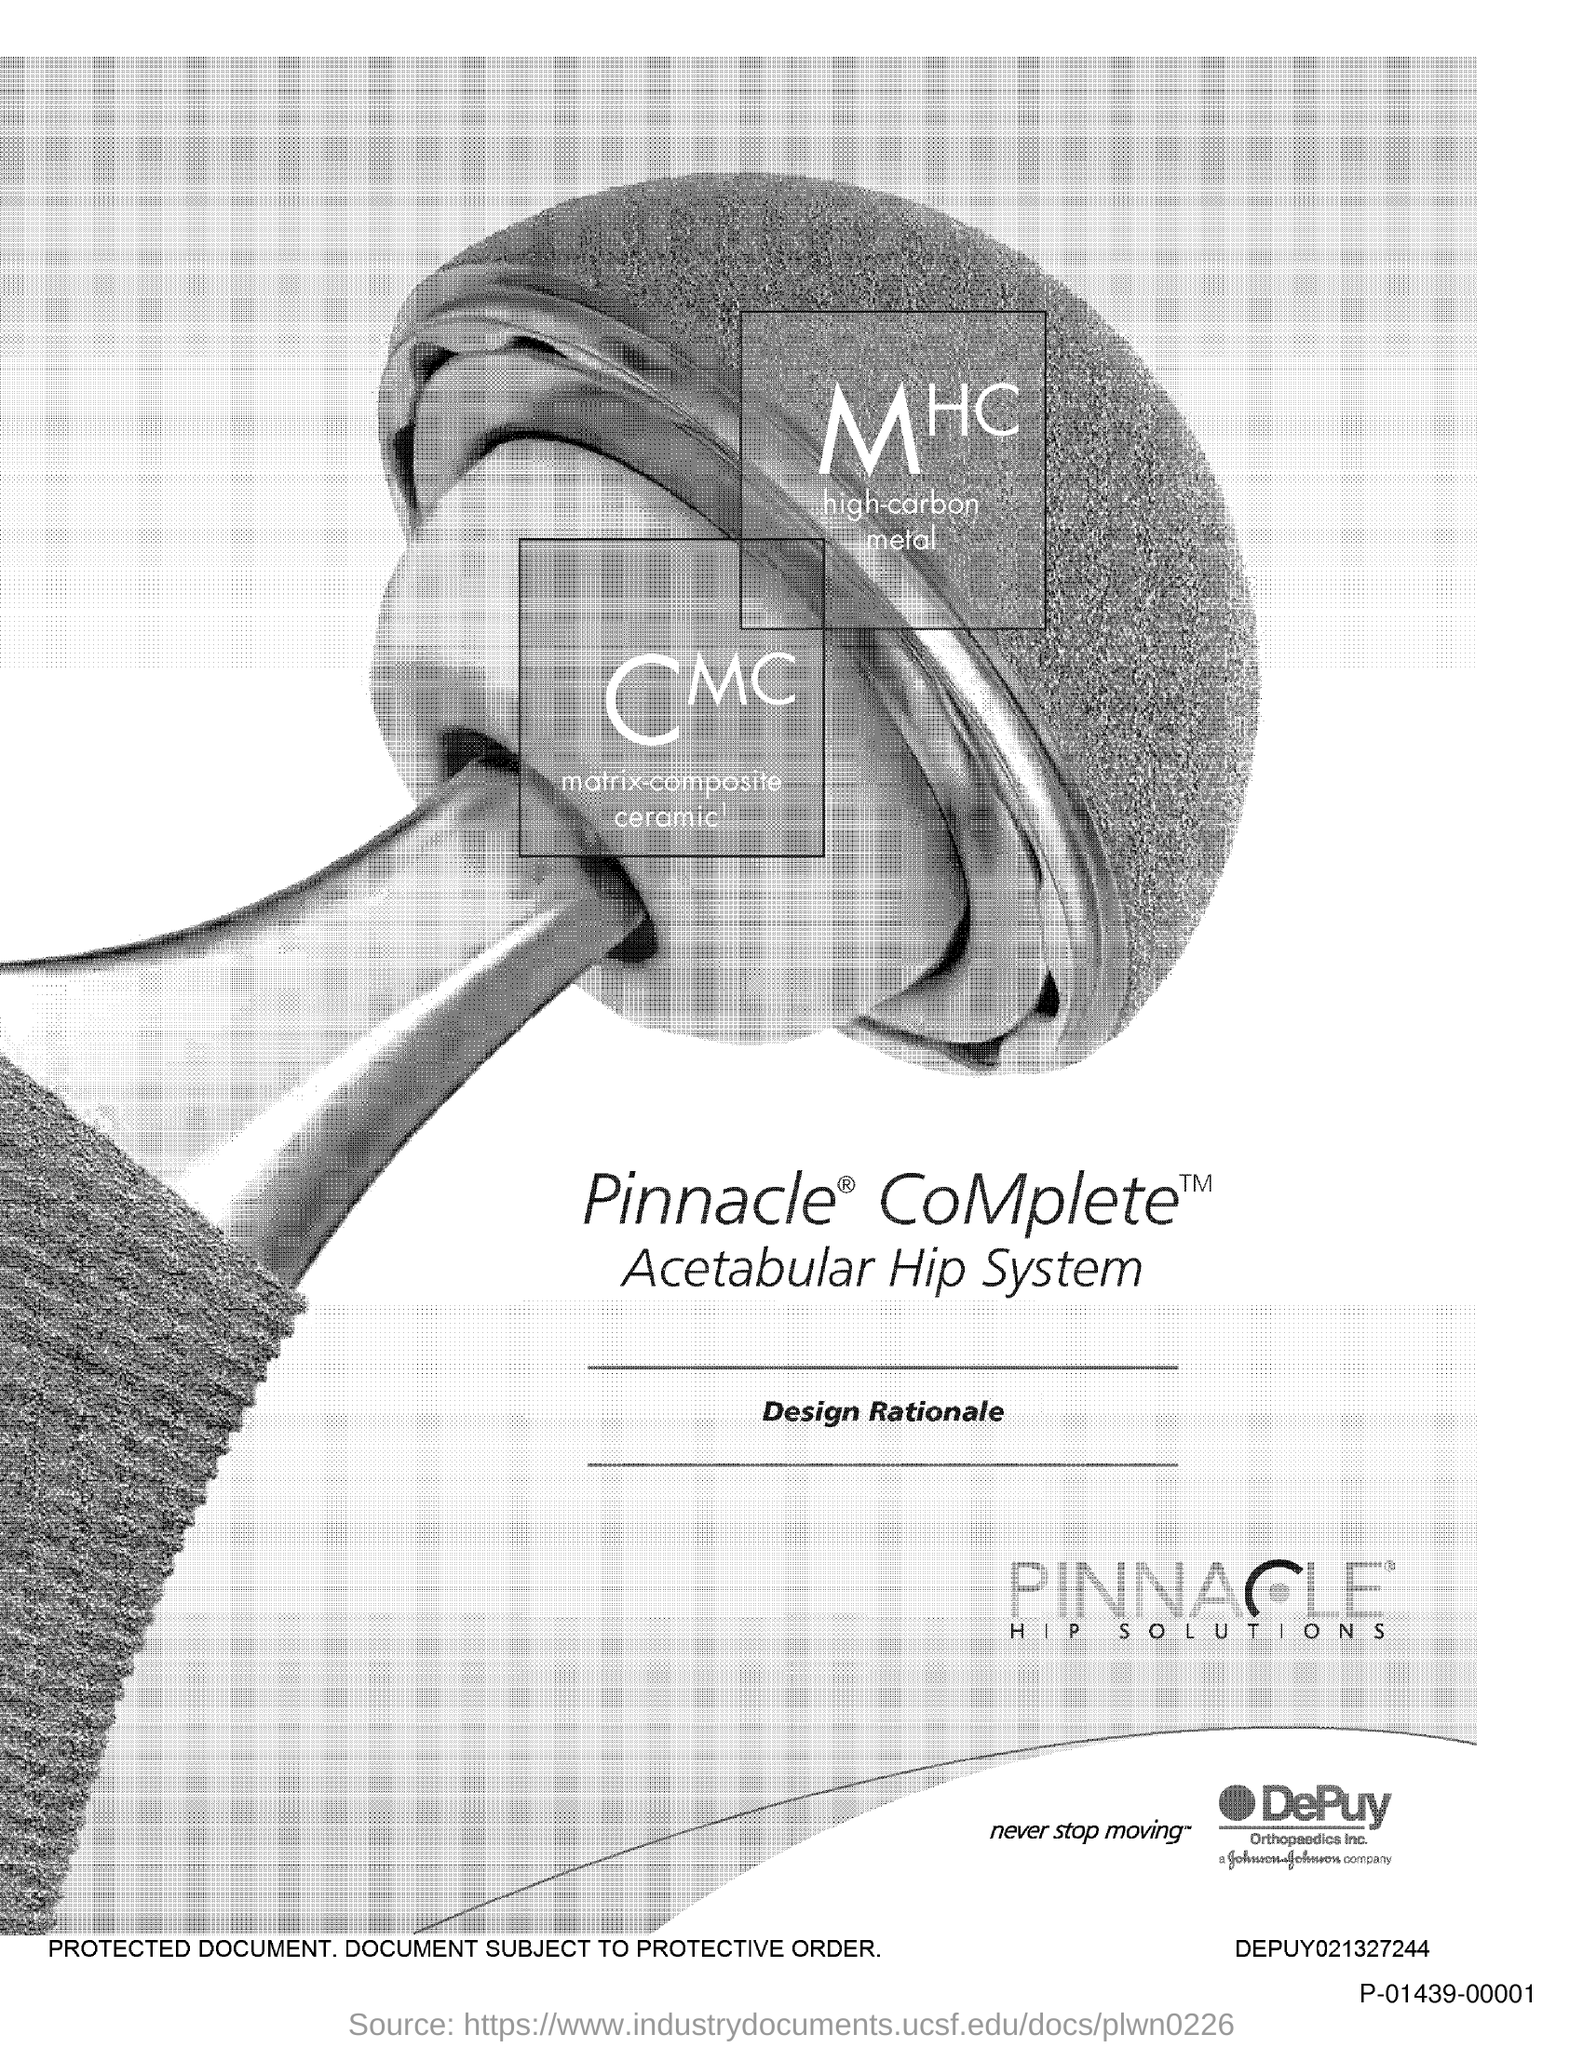What is the text written in-between the two lines?
Offer a very short reply. Design Rationale. 